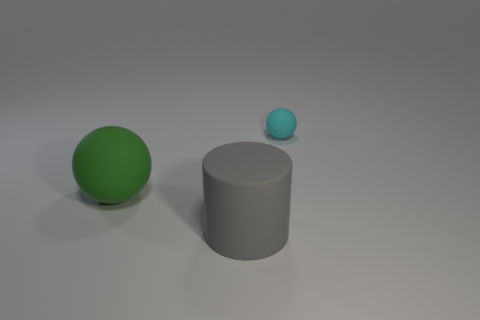What color is the object that is behind the big gray rubber cylinder and on the left side of the cyan thing?
Offer a terse response. Green. What number of objects are large matte objects right of the green ball or green rubber spheres?
Offer a very short reply. 2. What color is the other matte object that is the same shape as the large green matte object?
Your answer should be compact. Cyan. Does the green object have the same shape as the object on the right side of the large gray matte cylinder?
Make the answer very short. Yes. What number of objects are spheres to the right of the gray rubber object or rubber objects that are in front of the small cyan rubber ball?
Provide a succinct answer. 3. Is the number of matte cylinders in front of the cyan matte sphere less than the number of gray cylinders?
Offer a terse response. No. What is the large cylinder made of?
Offer a very short reply. Rubber. There is a big rubber cylinder; is it the same color as the matte ball left of the tiny thing?
Give a very brief answer. No. Is there anything else that has the same shape as the gray rubber object?
Give a very brief answer. No. What is the color of the big thing that is right of the big thing that is on the left side of the big gray matte object?
Give a very brief answer. Gray. 